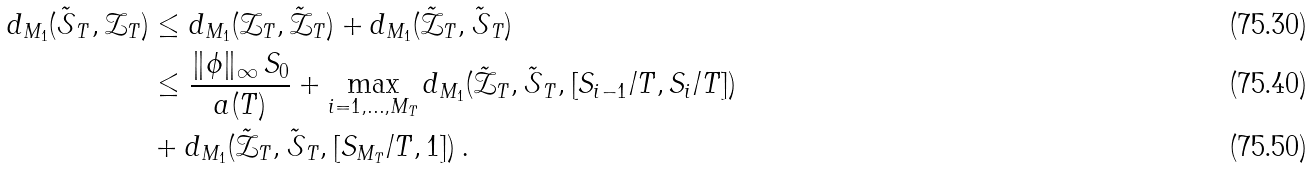<formula> <loc_0><loc_0><loc_500><loc_500>d _ { M _ { 1 } } ( \tilde { \mathcal { S } } _ { T } , \mathcal { Z } _ { T } ) & \leq d _ { M _ { 1 } } ( \mathcal { Z } _ { T } , \tilde { \mathcal { Z } } _ { T } ) + d _ { M _ { 1 } } ( \tilde { \mathcal { Z } } _ { T } , \tilde { \mathcal { S } } _ { T } ) \\ & \leq \frac { \| \phi \| _ { \infty } \, S _ { 0 } } { a ( T ) } + \max _ { i = 1 , \dots , M _ { T } } d _ { M _ { 1 } } ( \tilde { \mathcal { Z } } _ { T } , \tilde { \mathcal { S } } _ { T } , [ S _ { i - 1 } / T , S _ { i } / T ] ) \\ & + d _ { M _ { 1 } } ( \tilde { \mathcal { Z } } _ { T } , \tilde { \mathcal { S } } _ { T } , [ S _ { M _ { T } } / T , 1 ] ) \, .</formula> 